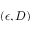<formula> <loc_0><loc_0><loc_500><loc_500>( \epsilon , D )</formula> 